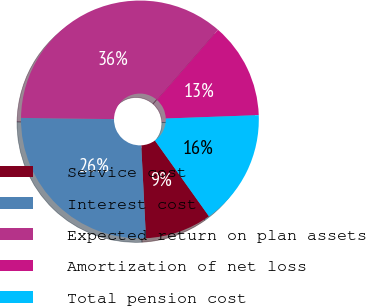Convert chart. <chart><loc_0><loc_0><loc_500><loc_500><pie_chart><fcel>Service cost<fcel>Interest cost<fcel>Expected return on plan assets<fcel>Amortization of net loss<fcel>Total pension cost<nl><fcel>9.05%<fcel>26.02%<fcel>36.2%<fcel>13.01%<fcel>15.72%<nl></chart> 